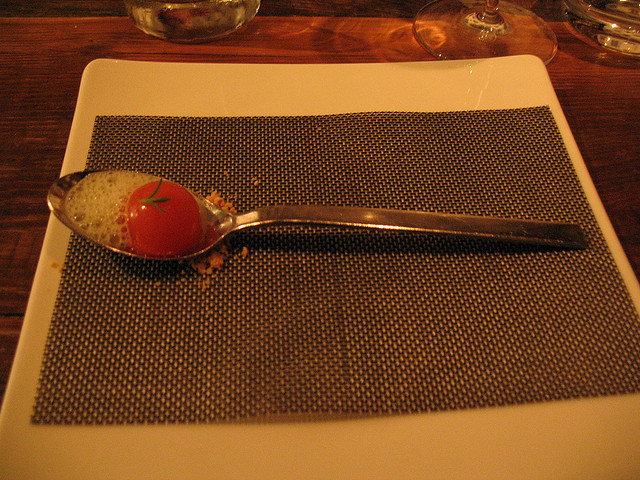How many bowls are there? There are no bowls visible in this image. We can see a spoon resting on a placemat, which has a single, tomato-shaped object on it that appears to be a culinary creation rather than an actual tomato. 